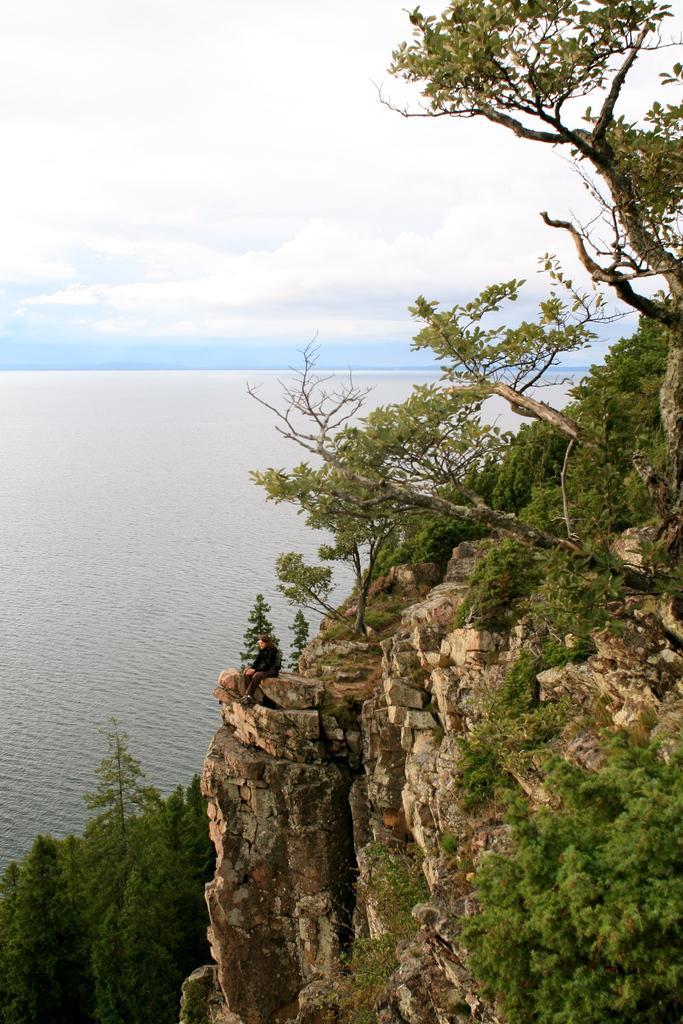How would you summarize this image in a sentence or two? There is water on the left side. On the right side there are trees, rock mountains. On that a person is sitting. In the background there is sky 